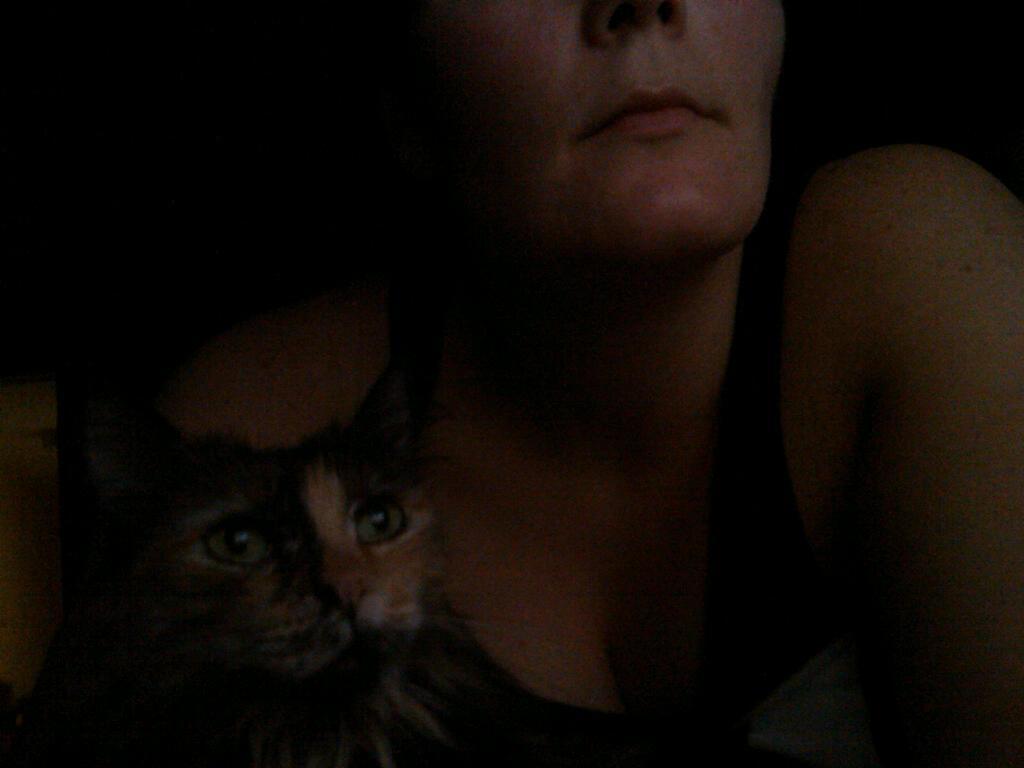Please provide a concise description of this image. This is a blur picture, we can see a woman and a cat. 